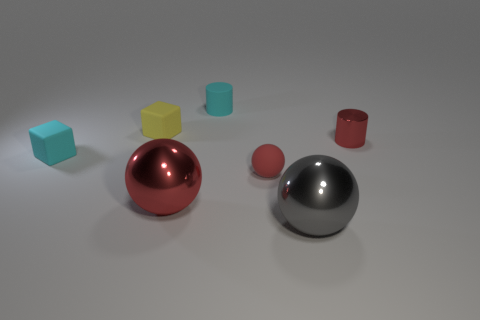Add 2 small yellow rubber cylinders. How many objects exist? 9 Subtract all cylinders. How many objects are left? 5 Add 7 small red matte things. How many small red matte things exist? 8 Subtract 0 brown spheres. How many objects are left? 7 Subtract all purple matte cylinders. Subtract all gray things. How many objects are left? 6 Add 2 large gray metal spheres. How many large gray metal spheres are left? 3 